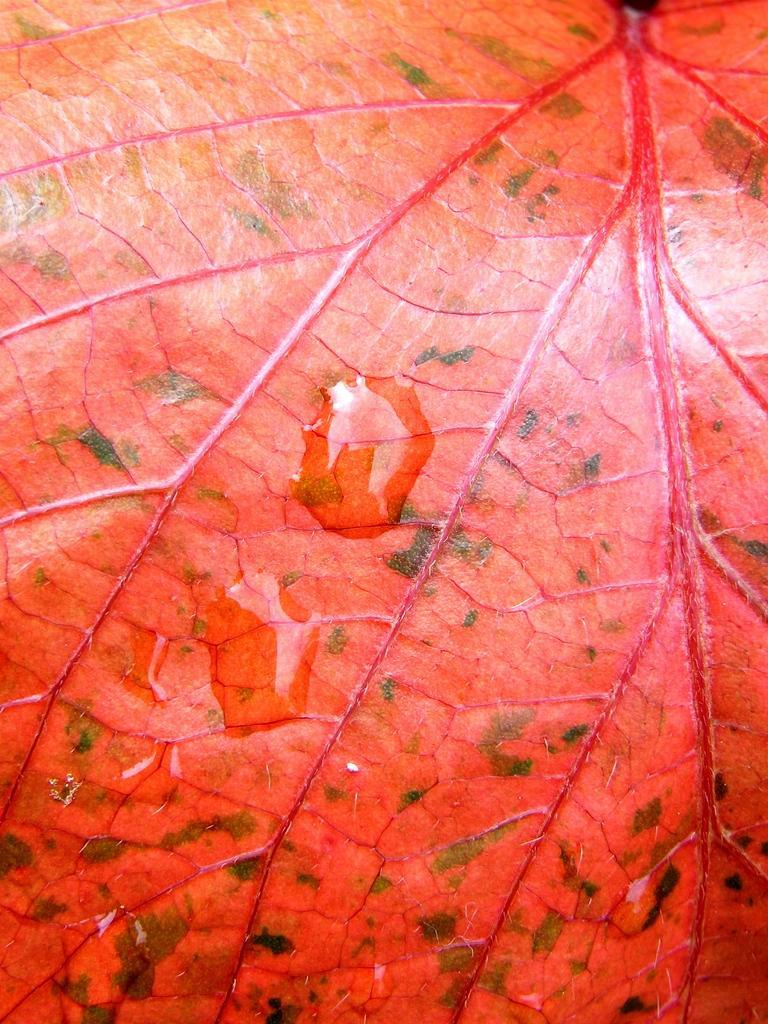Describe this image in one or two sentences. In this image, we can see the leaf, there are some water droplets on the leaf. 